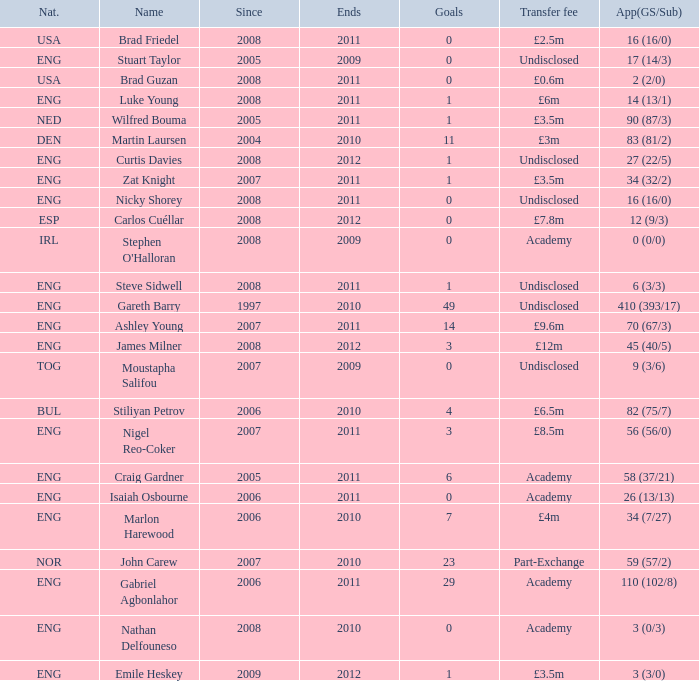Write the full table. {'header': ['Nat.', 'Name', 'Since', 'Ends', 'Goals', 'Transfer fee', 'App(GS/Sub)'], 'rows': [['USA', 'Brad Friedel', '2008', '2011', '0', '£2.5m', '16 (16/0)'], ['ENG', 'Stuart Taylor', '2005', '2009', '0', 'Undisclosed', '17 (14/3)'], ['USA', 'Brad Guzan', '2008', '2011', '0', '£0.6m', '2 (2/0)'], ['ENG', 'Luke Young', '2008', '2011', '1', '£6m', '14 (13/1)'], ['NED', 'Wilfred Bouma', '2005', '2011', '1', '£3.5m', '90 (87/3)'], ['DEN', 'Martin Laursen', '2004', '2010', '11', '£3m', '83 (81/2)'], ['ENG', 'Curtis Davies', '2008', '2012', '1', 'Undisclosed', '27 (22/5)'], ['ENG', 'Zat Knight', '2007', '2011', '1', '£3.5m', '34 (32/2)'], ['ENG', 'Nicky Shorey', '2008', '2011', '0', 'Undisclosed', '16 (16/0)'], ['ESP', 'Carlos Cuéllar', '2008', '2012', '0', '£7.8m', '12 (9/3)'], ['IRL', "Stephen O'Halloran", '2008', '2009', '0', 'Academy', '0 (0/0)'], ['ENG', 'Steve Sidwell', '2008', '2011', '1', 'Undisclosed', '6 (3/3)'], ['ENG', 'Gareth Barry', '1997', '2010', '49', 'Undisclosed', '410 (393/17)'], ['ENG', 'Ashley Young', '2007', '2011', '14', '£9.6m', '70 (67/3)'], ['ENG', 'James Milner', '2008', '2012', '3', '£12m', '45 (40/5)'], ['TOG', 'Moustapha Salifou', '2007', '2009', '0', 'Undisclosed', '9 (3/6)'], ['BUL', 'Stiliyan Petrov', '2006', '2010', '4', '£6.5m', '82 (75/7)'], ['ENG', 'Nigel Reo-Coker', '2007', '2011', '3', '£8.5m', '56 (56/0)'], ['ENG', 'Craig Gardner', '2005', '2011', '6', 'Academy', '58 (37/21)'], ['ENG', 'Isaiah Osbourne', '2006', '2011', '0', 'Academy', '26 (13/13)'], ['ENG', 'Marlon Harewood', '2006', '2010', '7', '£4m', '34 (7/27)'], ['NOR', 'John Carew', '2007', '2010', '23', 'Part-Exchange', '59 (57/2)'], ['ENG', 'Gabriel Agbonlahor', '2006', '2011', '29', 'Academy', '110 (102/8)'], ['ENG', 'Nathan Delfouneso', '2008', '2010', '0', 'Academy', '3 (0/3)'], ['ENG', 'Emile Heskey', '2009', '2012', '1', '£3.5m', '3 (3/0)']]} What is the greatest goals for Curtis Davies if ends is greater than 2012? None. 